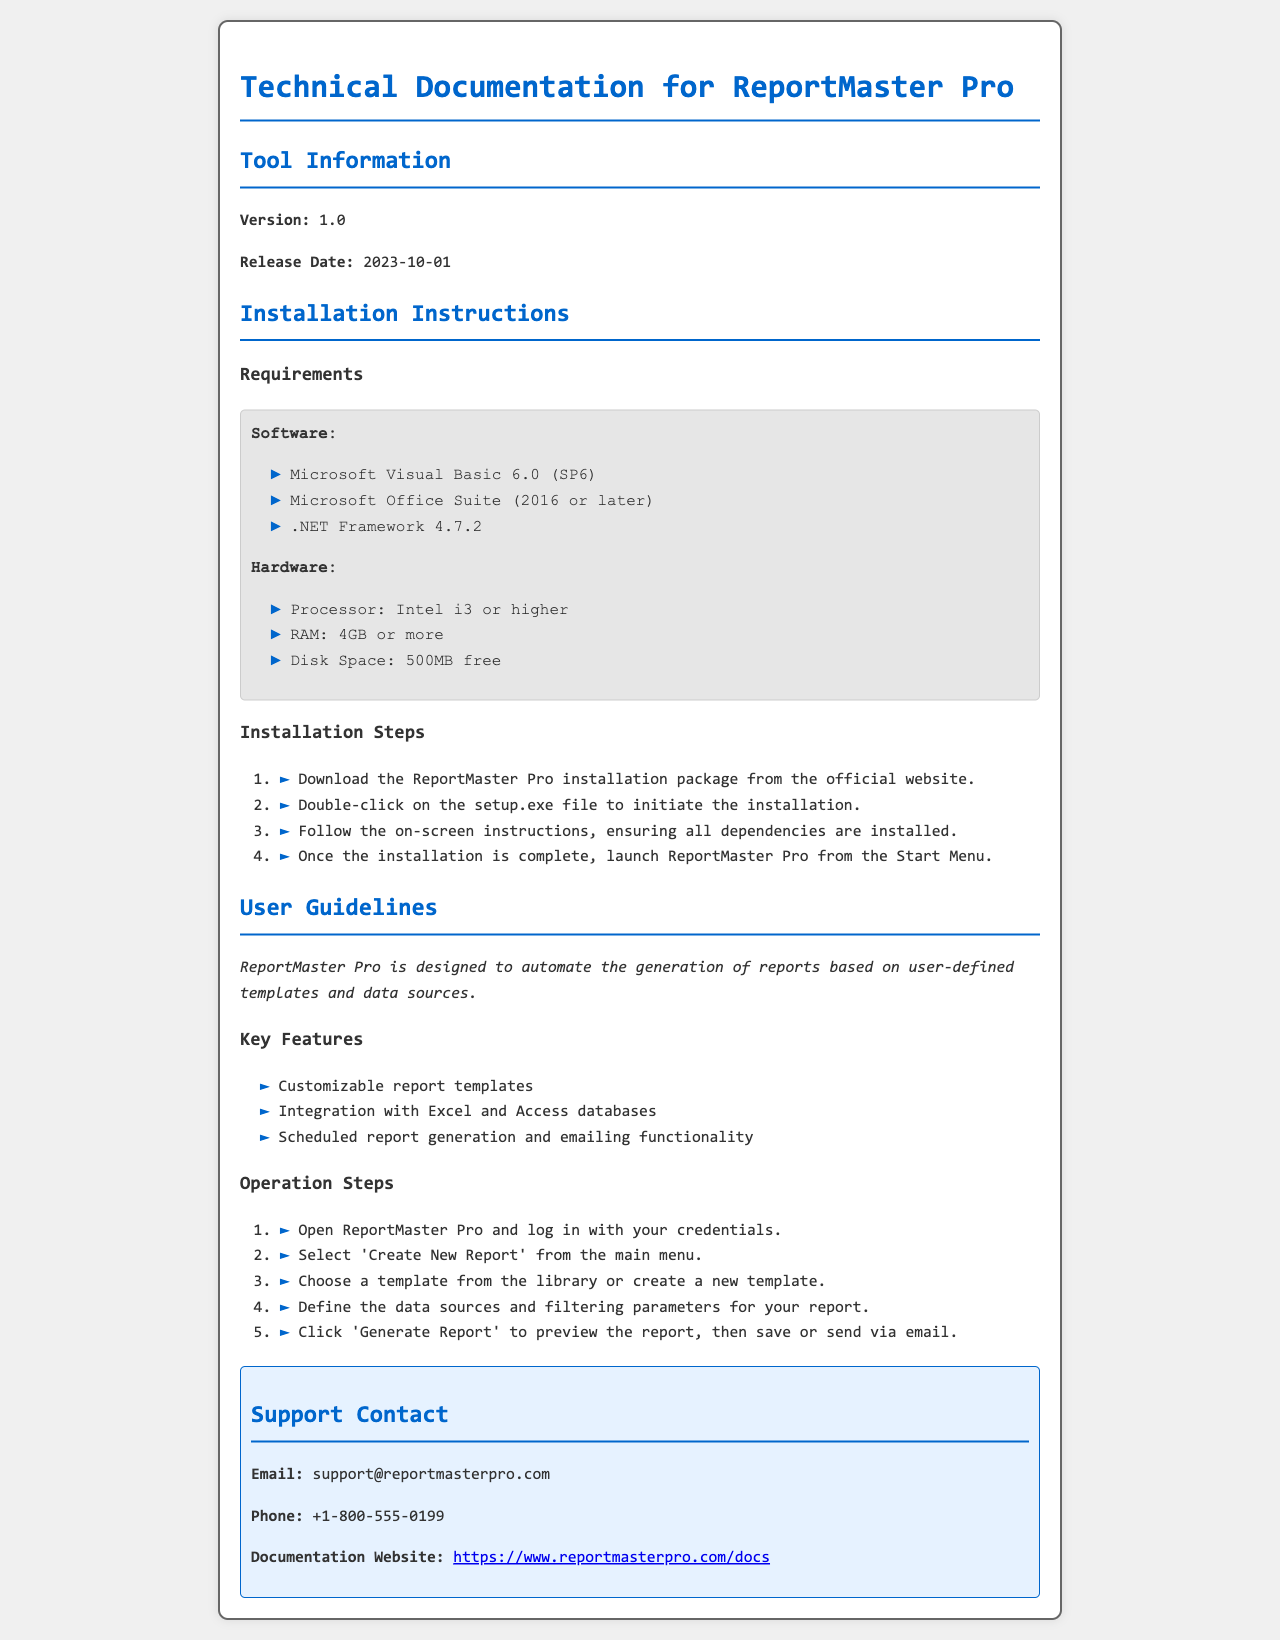What is the version of ReportMaster Pro? The version of ReportMaster Pro is specified in the document.
Answer: 1.0 When was ReportMaster Pro released? The release date is mentioned as part of the tool information.
Answer: 2023-10-01 What is required hardware RAM for installation? The hardware requirements state the minimum RAM required for installation.
Answer: 4GB or more Which software is needed alongside Microsoft Visual Basic 6.0? The installation instructions list necessary software including Microsoft Office Suite.
Answer: Microsoft Office Suite (2016 or later) Name one key feature of ReportMaster Pro. The user guidelines section lists several key features, of which any one can be mentioned.
Answer: Customizable report templates How do you initiate the installation of ReportMaster Pro? The installation steps outline the initial action needed to start the installation process.
Answer: Double-click on the setup.exe file What action is taken to generate a report in ReportMaster Pro? The operation steps define what the user must do to generate a report.
Answer: Click 'Generate Report' What is the support email for ReportMaster Pro? The support section provides contact information, including the email address.
Answer: support@reportmasterpro.com What type of document is this? The title reveals the nature of the document as technical documentation for a software tool.
Answer: Technical Documentation 